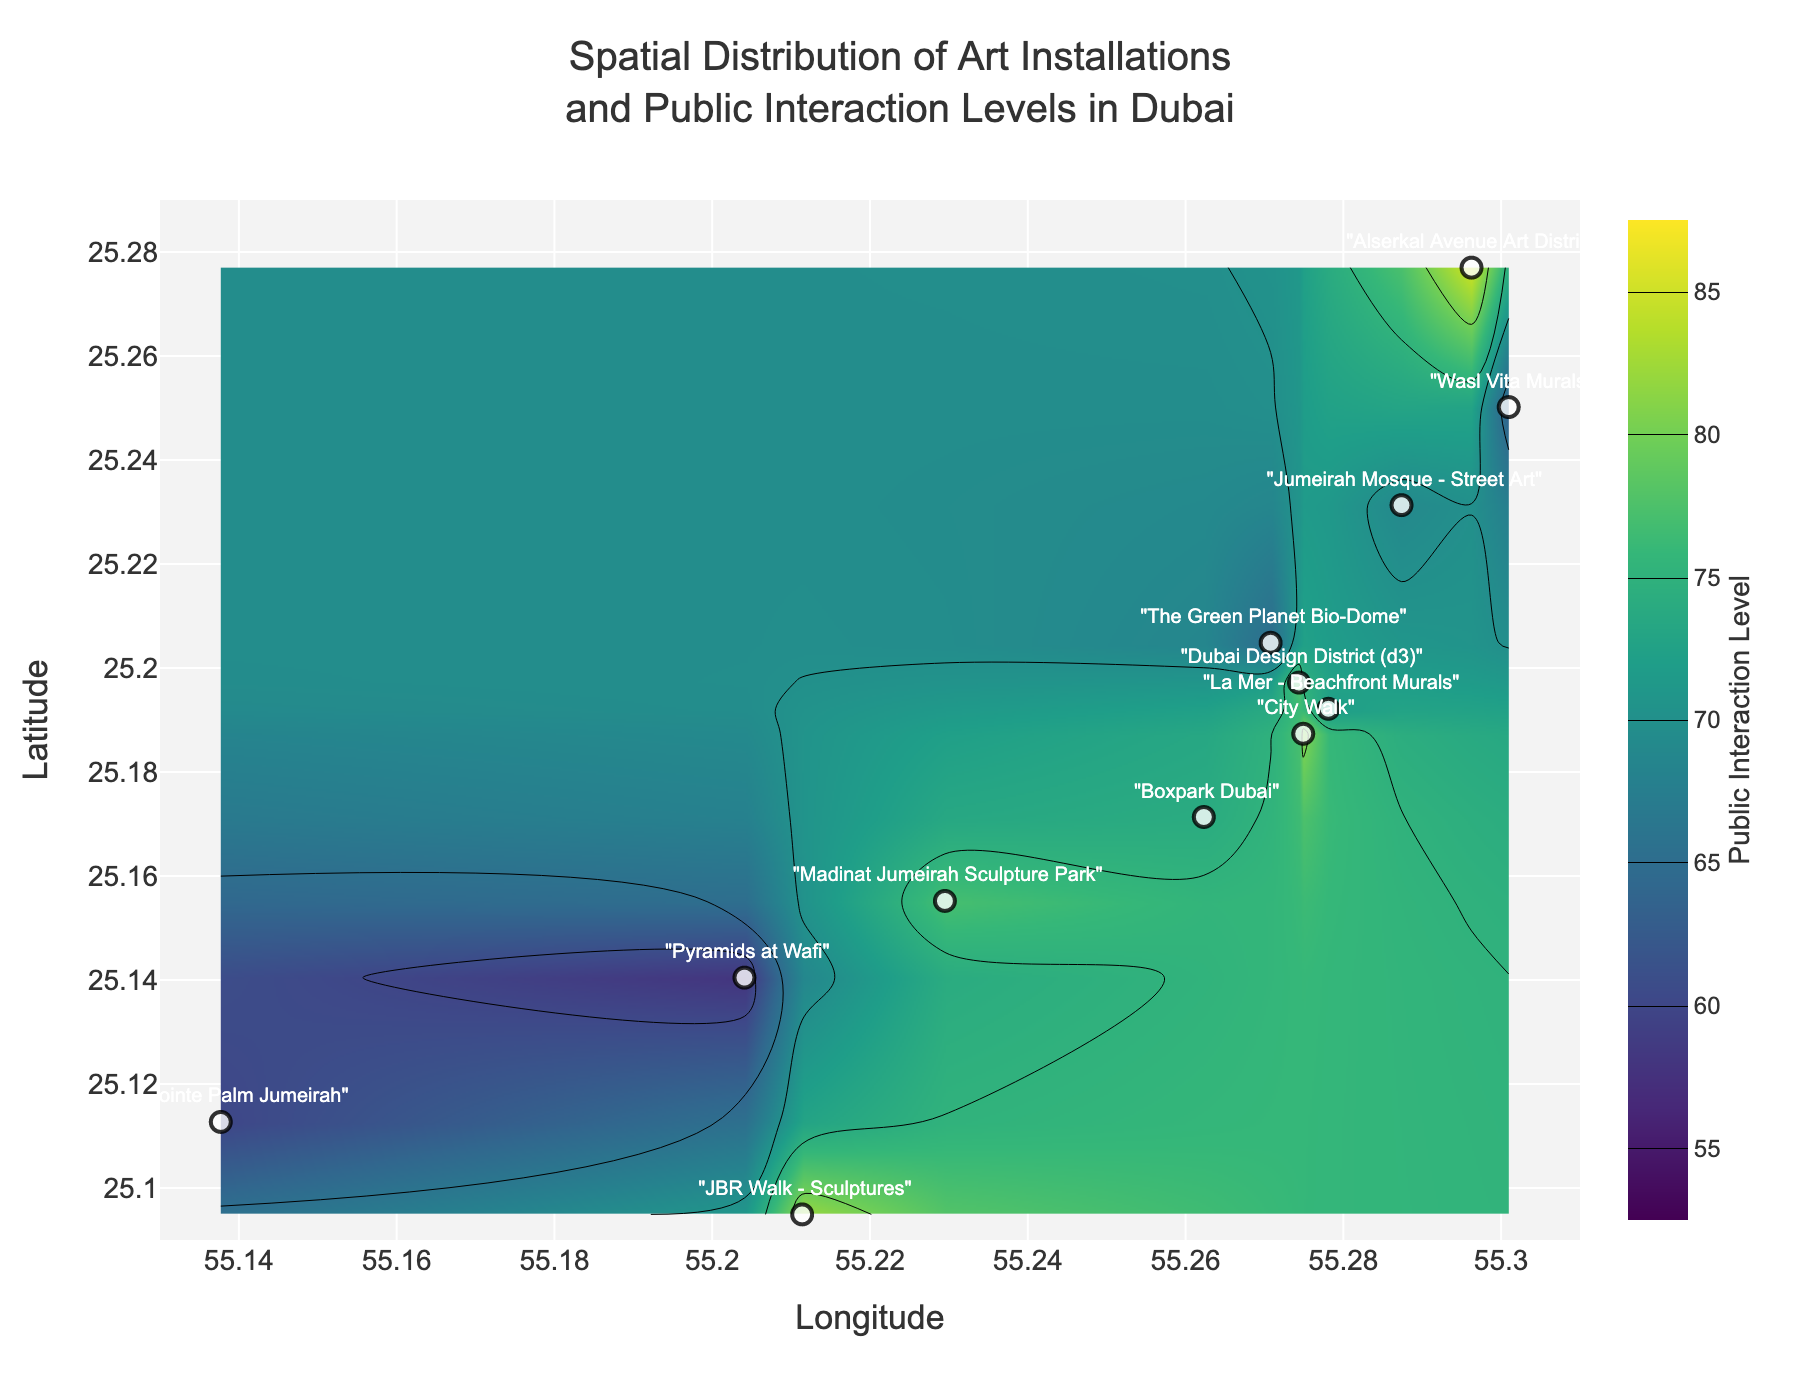What is the title of the figure? The title is at the top of the figure and describes what the plot represents. In this case, it is "Spatial Distribution of Art Installations and Public Interaction Levels in Dubai."
Answer: Spatial Distribution of Art Installations and Public Interaction Levels in Dubai How many art installations are marked on the map? The figure has text labels for each art installation. By counting these labels, we can see there are 12 art installations marked.
Answer: 12 What are the minimum and maximum public interaction levels shown in the color bar? The color bar on the right side of the figure shows the range of public interaction levels. The minimum is 55, and the maximum is 85.
Answer: 55 and 85 Which art installation has the highest public interaction level, and what is that level? By looking at the contour levels and markers, we can identify that "Alserkal Avenue Art District" has the highest public interaction level of 85.
Answer: Alserkal Avenue Art District, 85 What is the public interaction level at "City Walk"? Referring to the figure, the public interaction level associated with "City Walk" is labeled as 81.
Answer: 81 Which art installation is located closest to the longitude of 55.270782? By examining the longitude axis and the markers' positions, the closest installation is "The Green Planet Bio-Dome" located precisely at longitude 55.270782.
Answer: The Green Planet Bio-Dome Compare the public interaction levels of "JBR Walk - Sculptures" and "The Pointe Palm Jumeirah". Which one is higher? By looking at the public interaction levels marked for each, "JBR Walk - Sculptures" has a level of 82, and "The Pointe Palm Jumeirah" has a level of 60. "JBR Walk - Sculptures" is higher.
Answer: JBR Walk - Sculptures What is the average public interaction level of the installations in the Downtown Dubai area (including Alserkal Avenue, Dubai Design District, The Green Planet, La Mer, Boxpark, and City Walk)? Add the interaction levels of these installations (85, 78, 65, 72, 74, 81), then divide by the number of installations (6). The average is (85 + 78 + 65 + 72 + 74 + 81) / 6 = 75.83.
Answer: 75.83 What is the latitude range for the art installations shown in the figure? The latitude axis shows the range. By examining the markers' positions, they span from 25.09 to 25.276987.
Answer: 25.09 to 25.276987 Describe the trend in public interaction levels from the south to the north of the city as shown in the plot. As you move from south to north, referencing the contour coloring and levels, public interaction levels generally increase. The southern part (around The Pointe Palm Jumeirah) has lower interaction levels, while the northern part (around Alserkal Avenue) has higher levels.
Answer: Increasing from south to north 